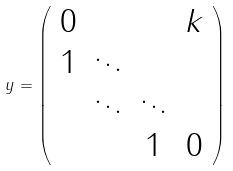Convert formula to latex. <formula><loc_0><loc_0><loc_500><loc_500>y = \left ( \begin{array} { c c c c } 0 & & & k \\ 1 & \ddots & & \\ & \ddots & \ddots & \\ & & 1 & 0 \end{array} \right )</formula> 